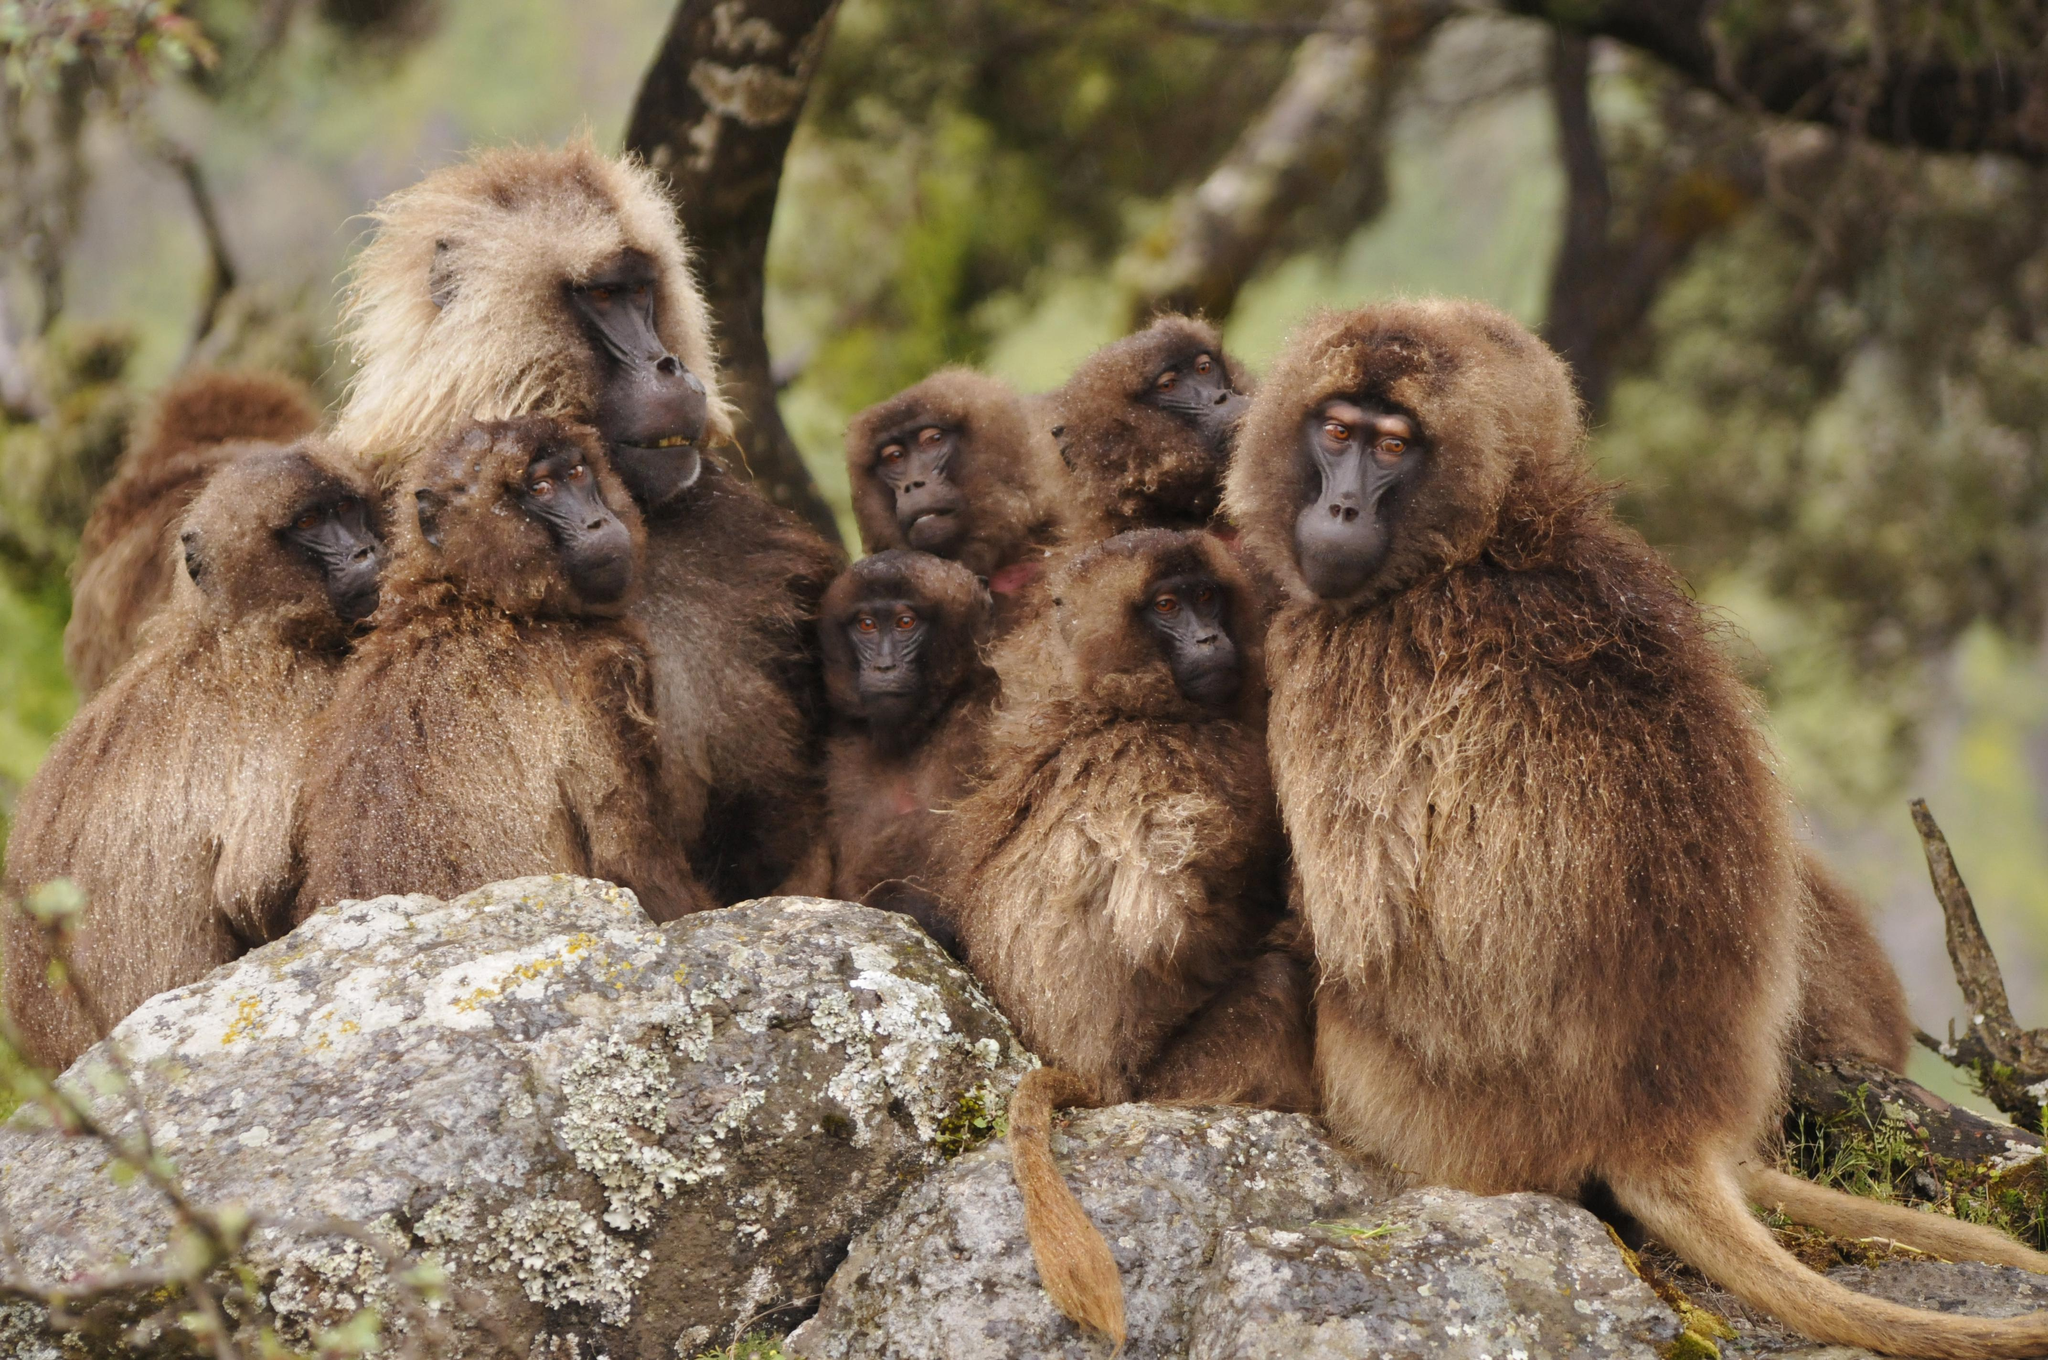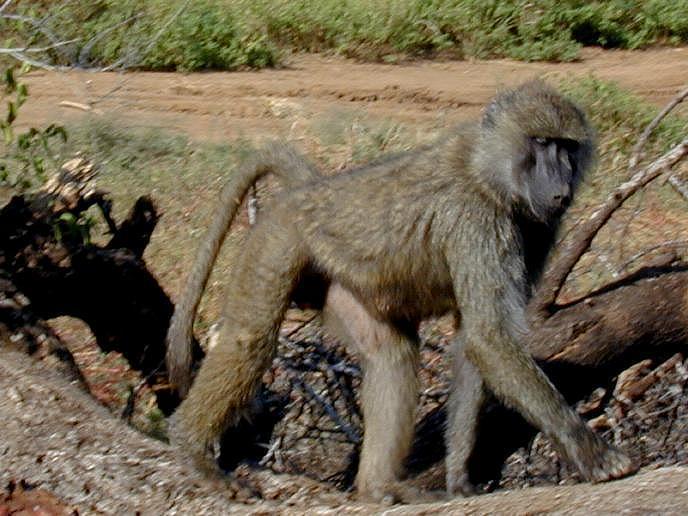The first image is the image on the left, the second image is the image on the right. Evaluate the accuracy of this statement regarding the images: "The right image contains fewer than a third of the number of baboons on the left.". Is it true? Answer yes or no. Yes. 